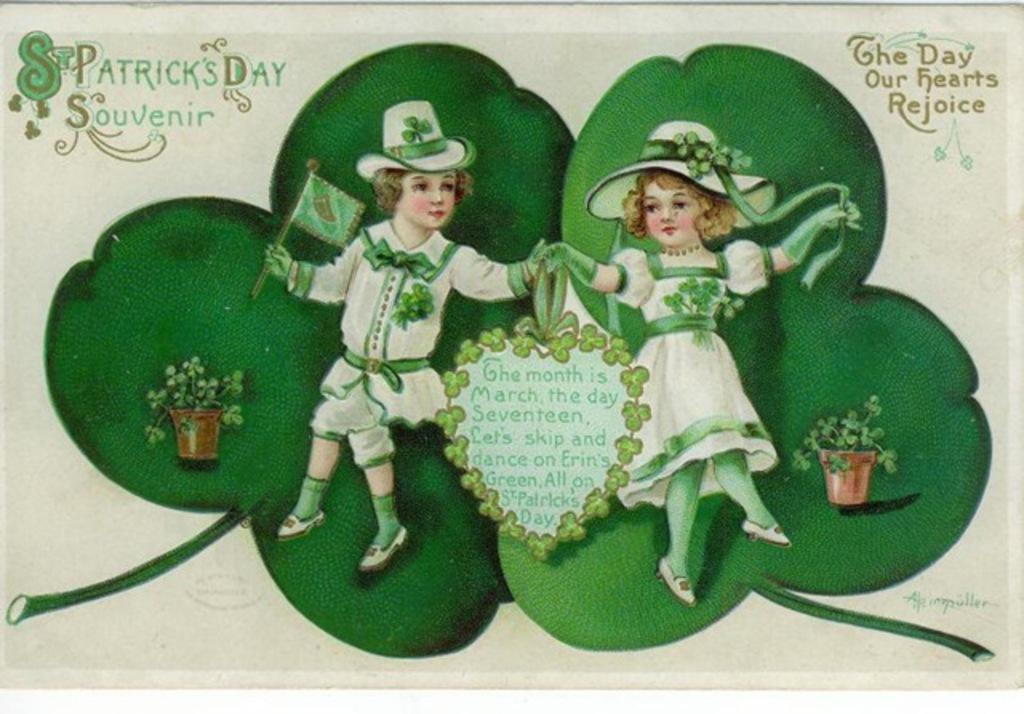Can you describe this image briefly? In this picture there is a poster on the wall. In that we can see the couples who are wearing the same dress and holding their hand and he is holding a flag. beside them we can see the pot and plants. 